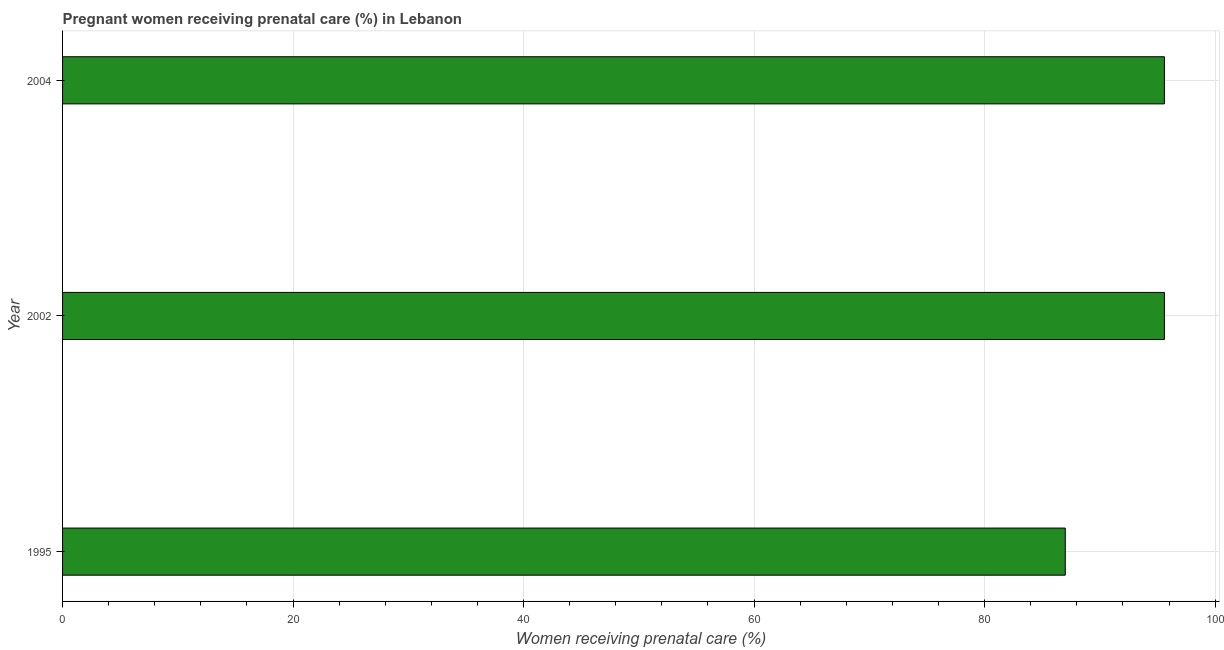Does the graph contain any zero values?
Your answer should be very brief. No. What is the title of the graph?
Offer a terse response. Pregnant women receiving prenatal care (%) in Lebanon. What is the label or title of the X-axis?
Offer a very short reply. Women receiving prenatal care (%). What is the percentage of pregnant women receiving prenatal care in 1995?
Offer a terse response. 87. Across all years, what is the maximum percentage of pregnant women receiving prenatal care?
Your answer should be compact. 95.6. What is the sum of the percentage of pregnant women receiving prenatal care?
Provide a short and direct response. 278.2. What is the difference between the percentage of pregnant women receiving prenatal care in 1995 and 2004?
Your answer should be compact. -8.6. What is the average percentage of pregnant women receiving prenatal care per year?
Give a very brief answer. 92.73. What is the median percentage of pregnant women receiving prenatal care?
Your answer should be very brief. 95.6. In how many years, is the percentage of pregnant women receiving prenatal care greater than 80 %?
Your answer should be very brief. 3. What is the ratio of the percentage of pregnant women receiving prenatal care in 1995 to that in 2002?
Make the answer very short. 0.91. Is the percentage of pregnant women receiving prenatal care in 2002 less than that in 2004?
Offer a terse response. No. Is the sum of the percentage of pregnant women receiving prenatal care in 1995 and 2004 greater than the maximum percentage of pregnant women receiving prenatal care across all years?
Ensure brevity in your answer.  Yes. In how many years, is the percentage of pregnant women receiving prenatal care greater than the average percentage of pregnant women receiving prenatal care taken over all years?
Your answer should be very brief. 2. How many bars are there?
Provide a short and direct response. 3. Are all the bars in the graph horizontal?
Your answer should be very brief. Yes. How many years are there in the graph?
Keep it short and to the point. 3. What is the difference between two consecutive major ticks on the X-axis?
Provide a short and direct response. 20. What is the Women receiving prenatal care (%) in 2002?
Your response must be concise. 95.6. What is the Women receiving prenatal care (%) of 2004?
Provide a succinct answer. 95.6. What is the difference between the Women receiving prenatal care (%) in 1995 and 2002?
Your answer should be very brief. -8.6. What is the difference between the Women receiving prenatal care (%) in 2002 and 2004?
Ensure brevity in your answer.  0. What is the ratio of the Women receiving prenatal care (%) in 1995 to that in 2002?
Offer a terse response. 0.91. What is the ratio of the Women receiving prenatal care (%) in 1995 to that in 2004?
Offer a very short reply. 0.91. 